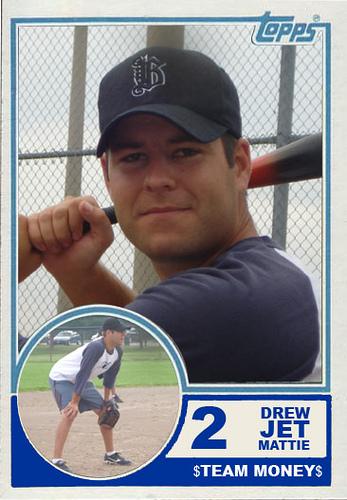What is the man squatting for?
Give a very brief answer. In position to catch. What is his name?
Quick response, please. Drew. What is he holding in his hands?
Be succinct. Bat. 